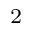<formula> <loc_0><loc_0><loc_500><loc_500>_ { 2 }</formula> 